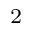<formula> <loc_0><loc_0><loc_500><loc_500>_ { 2 }</formula> 